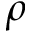<formula> <loc_0><loc_0><loc_500><loc_500>\rho</formula> 